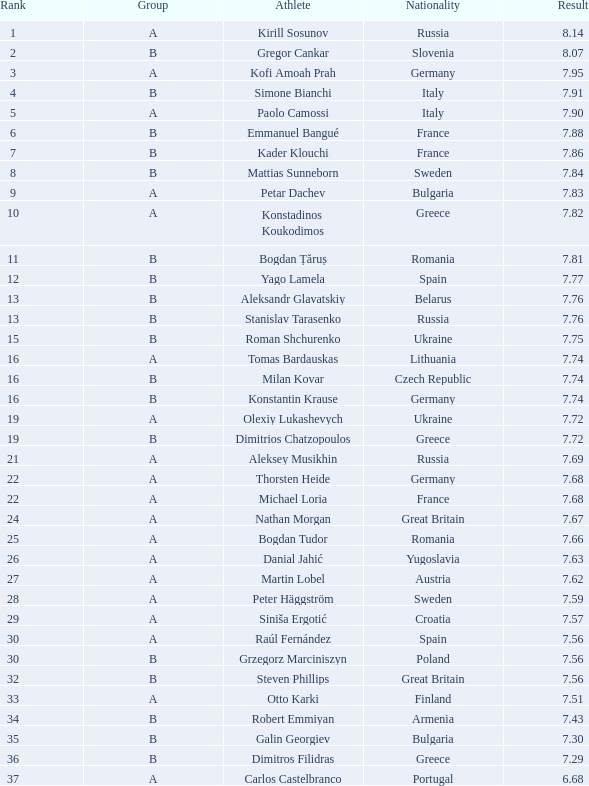Which athlete's rank is more than 15 when the result is less than 7.68, the group is b, and the nationality listed is Great Britain? Steven Phillips. 